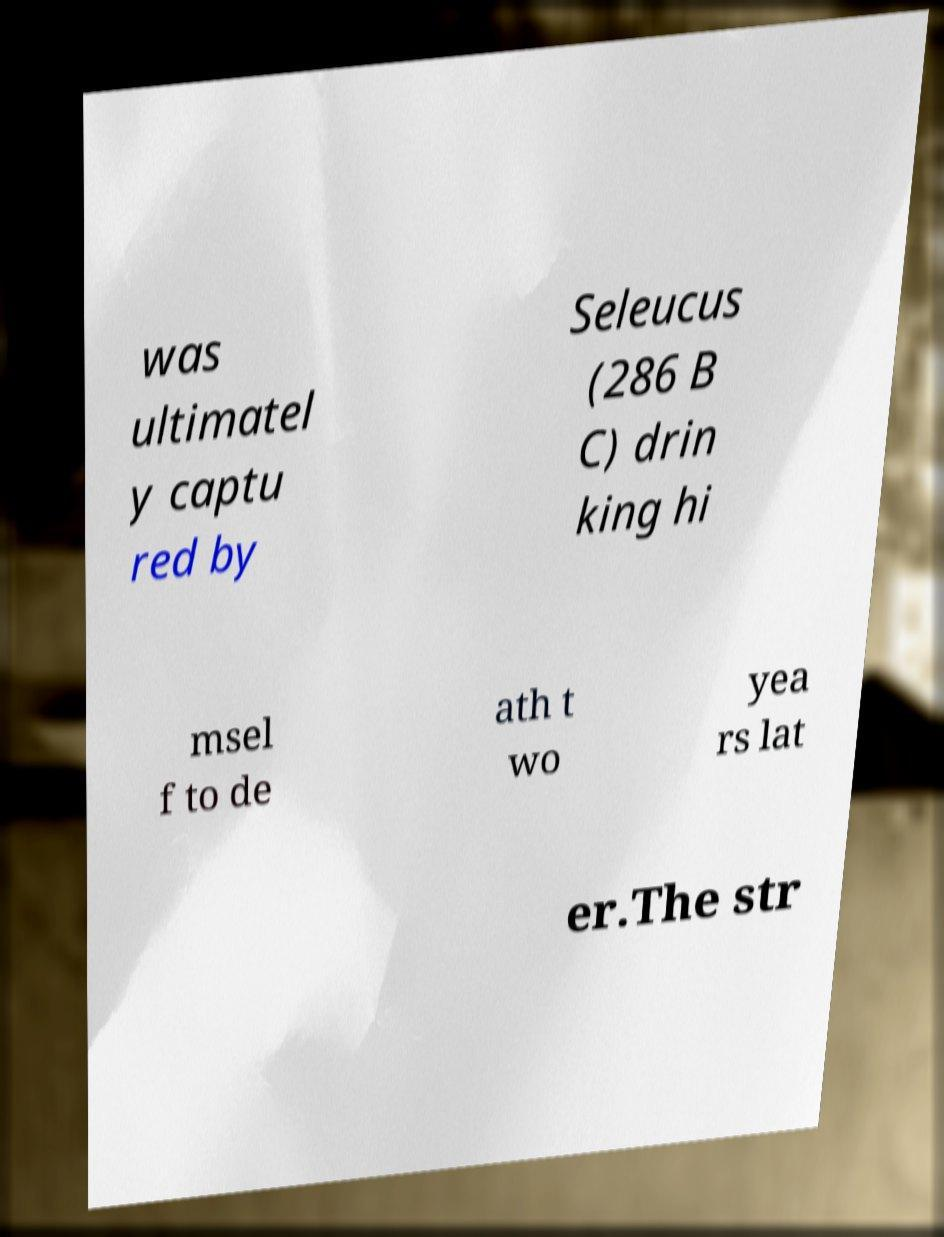Please read and relay the text visible in this image. What does it say? was ultimatel y captu red by Seleucus (286 B C) drin king hi msel f to de ath t wo yea rs lat er.The str 